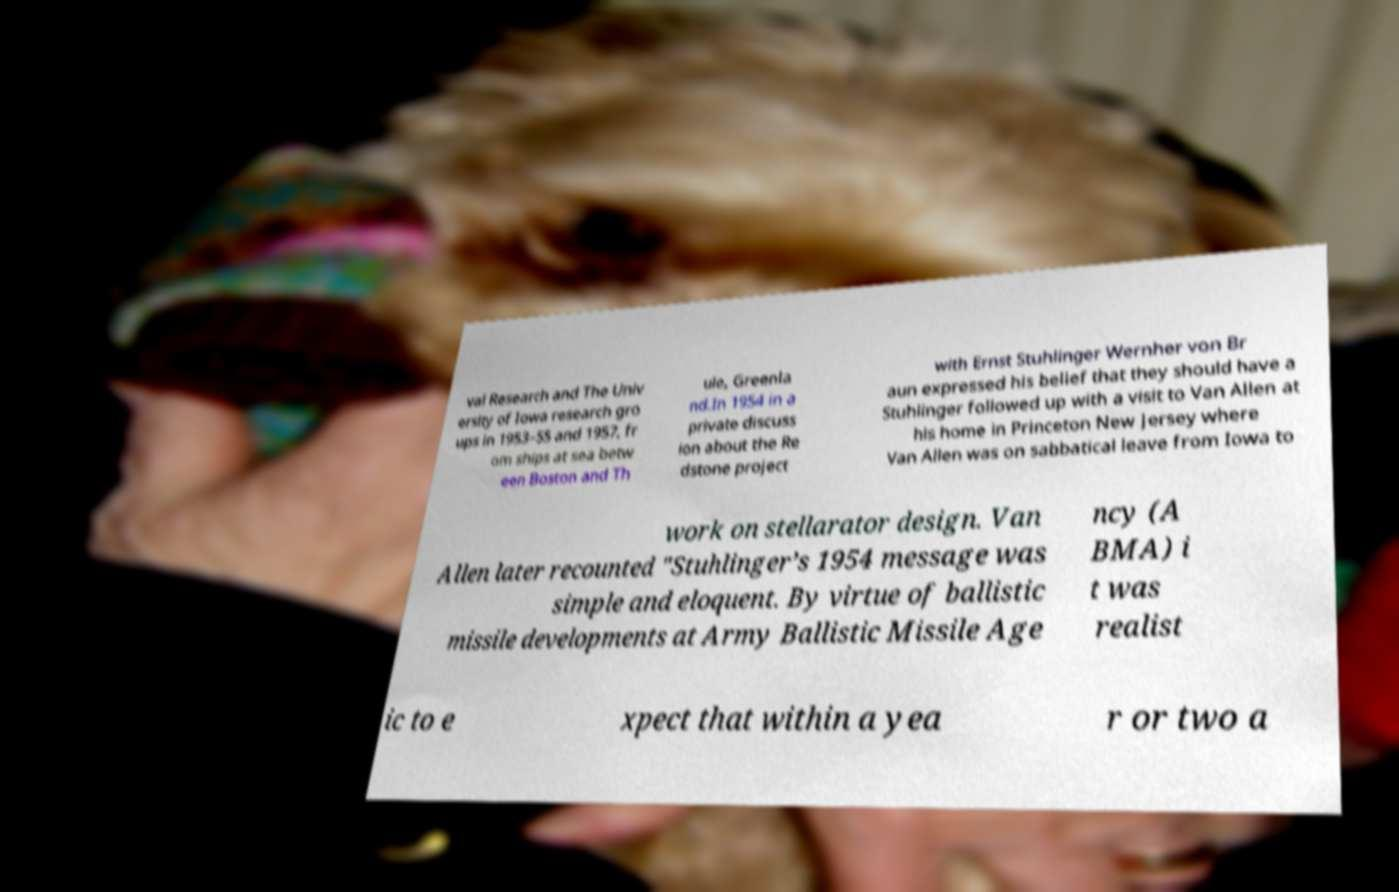Could you assist in decoding the text presented in this image and type it out clearly? val Research and The Univ ersity of Iowa research gro ups in 1953–55 and 1957, fr om ships at sea betw een Boston and Th ule, Greenla nd.In 1954 in a private discuss ion about the Re dstone project with Ernst Stuhlinger Wernher von Br aun expressed his belief that they should have a Stuhlinger followed up with a visit to Van Allen at his home in Princeton New Jersey where Van Allen was on sabbatical leave from Iowa to work on stellarator design. Van Allen later recounted "Stuhlinger’s 1954 message was simple and eloquent. By virtue of ballistic missile developments at Army Ballistic Missile Age ncy (A BMA) i t was realist ic to e xpect that within a yea r or two a 